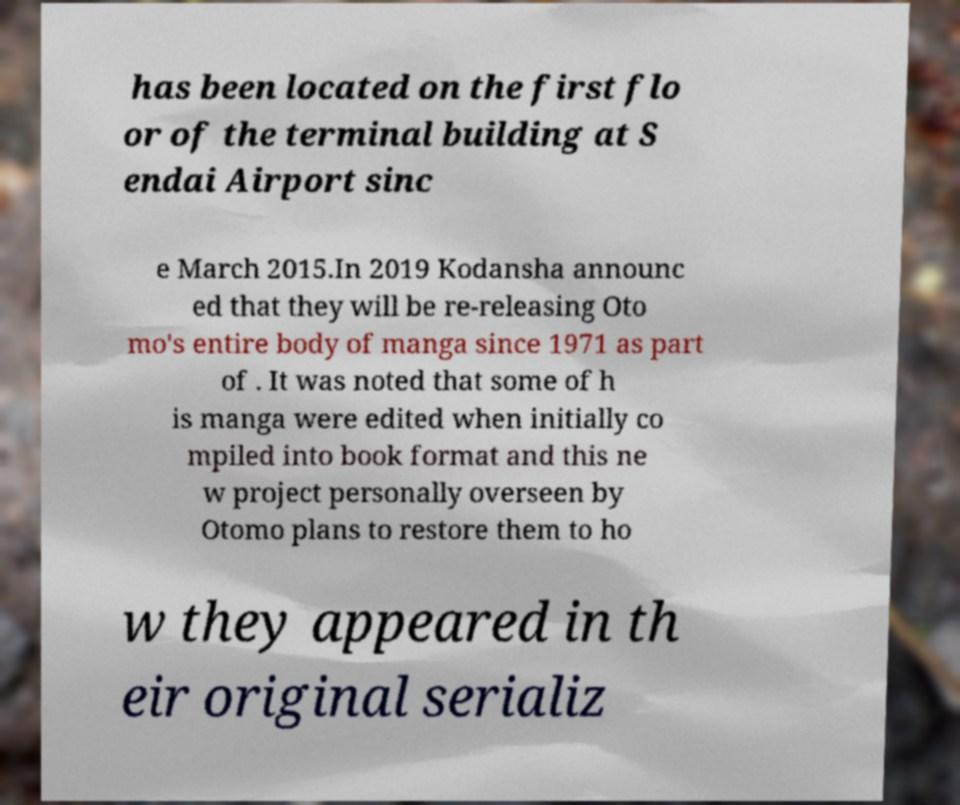Could you extract and type out the text from this image? has been located on the first flo or of the terminal building at S endai Airport sinc e March 2015.In 2019 Kodansha announc ed that they will be re-releasing Oto mo's entire body of manga since 1971 as part of . It was noted that some of h is manga were edited when initially co mpiled into book format and this ne w project personally overseen by Otomo plans to restore them to ho w they appeared in th eir original serializ 